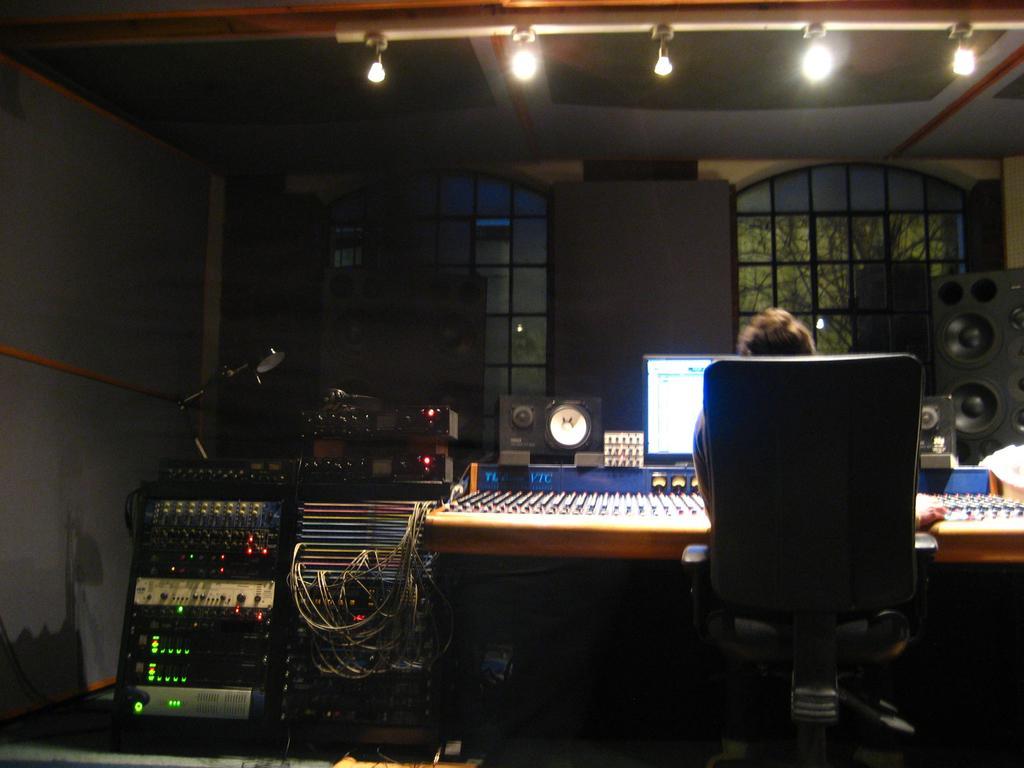In one or two sentences, can you explain what this image depicts? In this picture there is a person sitting on a chair and we can see devices, speakers and monitor. In the background of the image we can see wall and windows. At the top of the image we can see lights. 